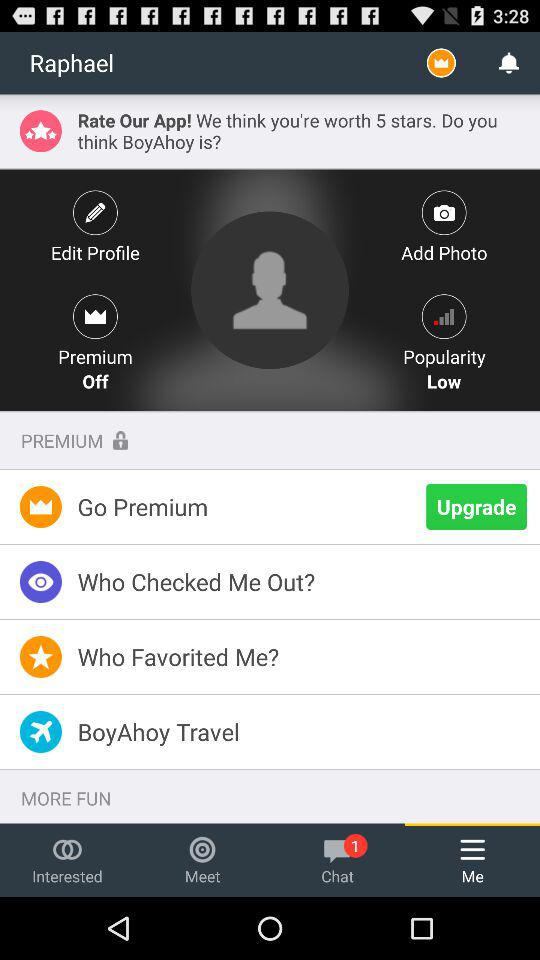What is "Popularity"?
Answer the question using a single word or phrase. It is low. 